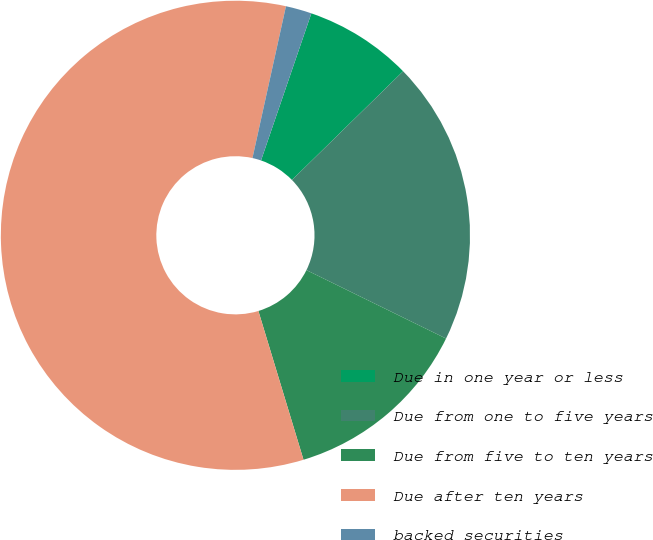Convert chart. <chart><loc_0><loc_0><loc_500><loc_500><pie_chart><fcel>Due in one year or less<fcel>Due from one to five years<fcel>Due from five to ten years<fcel>Due after ten years<fcel>backed securities<nl><fcel>7.43%<fcel>19.58%<fcel>13.06%<fcel>58.15%<fcel>1.79%<nl></chart> 